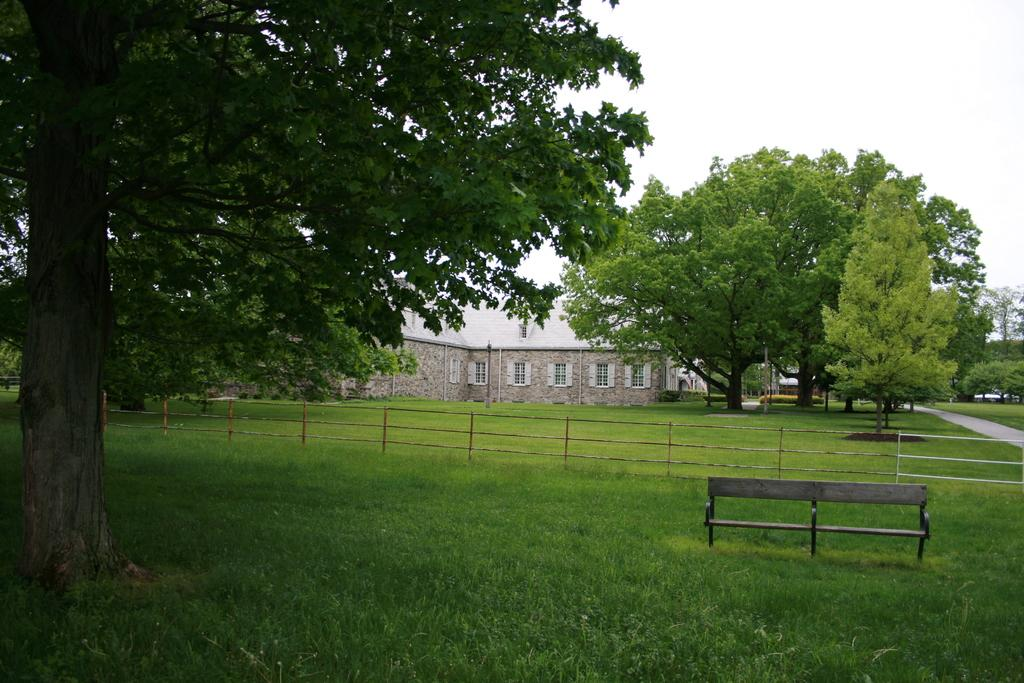What type of terrain is visible in the image? The ground with grass is visible in the image. What natural elements can be seen in the image? There are trees in the image. What man-made structures are present in the image? Poles, a bench, fencing, and a building with windows are visible in the image. What part of the natural environment is visible in the image? The sky is visible in the image. What type of collar is being worn by the tree in the image? There is no collar present on the tree in the image, as trees do not wear collars. How many mines can be seen in the image? There are no mines present in the image. 